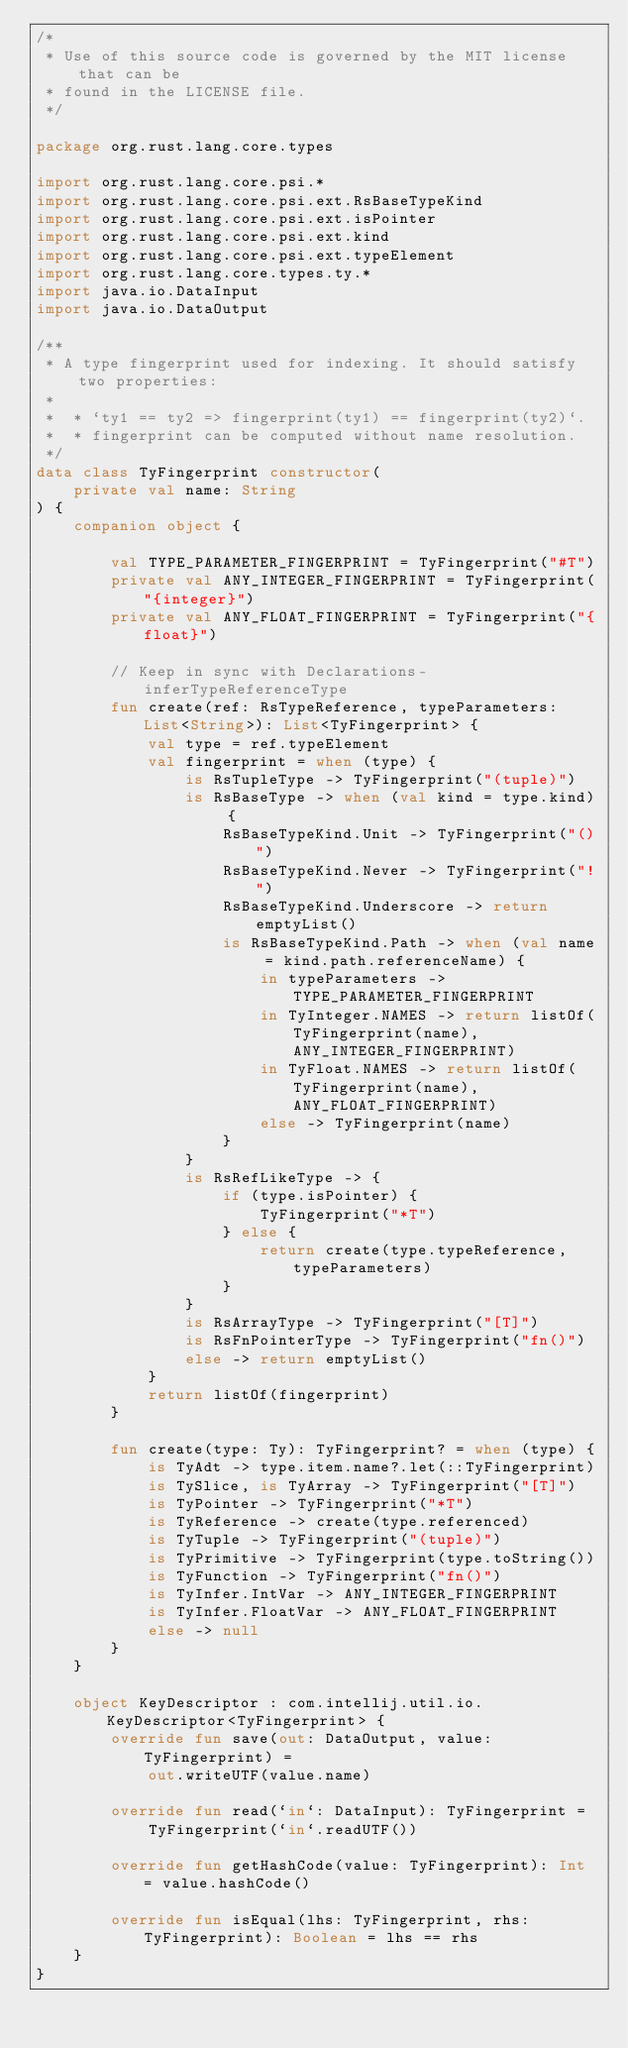<code> <loc_0><loc_0><loc_500><loc_500><_Kotlin_>/*
 * Use of this source code is governed by the MIT license that can be
 * found in the LICENSE file.
 */

package org.rust.lang.core.types

import org.rust.lang.core.psi.*
import org.rust.lang.core.psi.ext.RsBaseTypeKind
import org.rust.lang.core.psi.ext.isPointer
import org.rust.lang.core.psi.ext.kind
import org.rust.lang.core.psi.ext.typeElement
import org.rust.lang.core.types.ty.*
import java.io.DataInput
import java.io.DataOutput

/**
 * A type fingerprint used for indexing. It should satisfy two properties:
 *
 *  * `ty1 == ty2 => fingerprint(ty1) == fingerprint(ty2)`.
 *  * fingerprint can be computed without name resolution.
 */
data class TyFingerprint constructor(
    private val name: String
) {
    companion object {

        val TYPE_PARAMETER_FINGERPRINT = TyFingerprint("#T")
        private val ANY_INTEGER_FINGERPRINT = TyFingerprint("{integer}")
        private val ANY_FLOAT_FINGERPRINT = TyFingerprint("{float}")

        // Keep in sync with Declarations-inferTypeReferenceType
        fun create(ref: RsTypeReference, typeParameters: List<String>): List<TyFingerprint> {
            val type = ref.typeElement
            val fingerprint = when (type) {
                is RsTupleType -> TyFingerprint("(tuple)")
                is RsBaseType -> when (val kind = type.kind) {
                    RsBaseTypeKind.Unit -> TyFingerprint("()")
                    RsBaseTypeKind.Never -> TyFingerprint("!")
                    RsBaseTypeKind.Underscore -> return emptyList()
                    is RsBaseTypeKind.Path -> when (val name = kind.path.referenceName) {
                        in typeParameters -> TYPE_PARAMETER_FINGERPRINT
                        in TyInteger.NAMES -> return listOf(TyFingerprint(name), ANY_INTEGER_FINGERPRINT)
                        in TyFloat.NAMES -> return listOf(TyFingerprint(name), ANY_FLOAT_FINGERPRINT)
                        else -> TyFingerprint(name)
                    }
                }
                is RsRefLikeType -> {
                    if (type.isPointer) {
                        TyFingerprint("*T")
                    } else {
                        return create(type.typeReference, typeParameters)
                    }
                }
                is RsArrayType -> TyFingerprint("[T]")
                is RsFnPointerType -> TyFingerprint("fn()")
                else -> return emptyList()
            }
            return listOf(fingerprint)
        }

        fun create(type: Ty): TyFingerprint? = when (type) {
            is TyAdt -> type.item.name?.let(::TyFingerprint)
            is TySlice, is TyArray -> TyFingerprint("[T]")
            is TyPointer -> TyFingerprint("*T")
            is TyReference -> create(type.referenced)
            is TyTuple -> TyFingerprint("(tuple)")
            is TyPrimitive -> TyFingerprint(type.toString())
            is TyFunction -> TyFingerprint("fn()")
            is TyInfer.IntVar -> ANY_INTEGER_FINGERPRINT
            is TyInfer.FloatVar -> ANY_FLOAT_FINGERPRINT
            else -> null
        }
    }

    object KeyDescriptor : com.intellij.util.io.KeyDescriptor<TyFingerprint> {
        override fun save(out: DataOutput, value: TyFingerprint) =
            out.writeUTF(value.name)

        override fun read(`in`: DataInput): TyFingerprint =
            TyFingerprint(`in`.readUTF())

        override fun getHashCode(value: TyFingerprint): Int = value.hashCode()

        override fun isEqual(lhs: TyFingerprint, rhs: TyFingerprint): Boolean = lhs == rhs
    }
}
</code> 